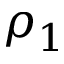Convert formula to latex. <formula><loc_0><loc_0><loc_500><loc_500>\rho _ { 1 }</formula> 